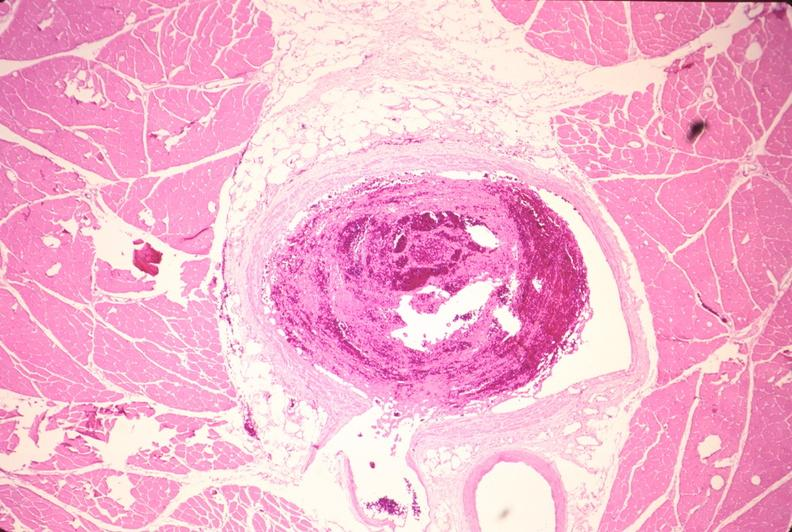s vasculature present?
Answer the question using a single word or phrase. Yes 